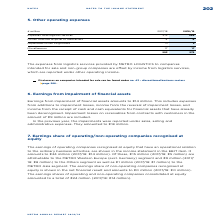According to Metro Ag's financial document, What is offset by income from logistics services? The expenses from logistics services provided by METRO LOGISTICS to companies intended for sale and non-group companies. The document states: "The expenses from logistics services provided by METRO LOGISTICS to companies intended for sale and non-group companies are offset by income from logi..." Also, Where is income from logistics services reported? reported under other operating income.. The document states: "which are reported under other operating income...." Also, What are the components under Other operating expenses in the table? The document contains multiple relevant values: Expenses from logistics services, Losses from the disposal of fixed assets, Impairment losses on goodwill, Miscellaneous. From the document: "Losses from the disposal of fixed assets 4 6 Miscellaneous 17 17 Impairment losses on goodwill 0 3 Expenses from logistics services 272 254..." Additionally, In which year was the amount of Losses from the disposal of fixed assets larger? Based on the financial document, the answer is 2018/2019. Also, can you calculate: What was the change in Losses from the disposal of fixed assets in 2018/2019 from 2017/2018? Based on the calculation: 6-4, the result is 2 (in millions). This is based on the information: "Losses from the disposal of fixed assets 4 6 Losses from the disposal of fixed assets 4 6..." The key data points involved are: 4, 6. Also, can you calculate: What was the percentage change in Losses from the disposal of fixed assets in 2018/2019 from 2017/2018? To answer this question, I need to perform calculations using the financial data. The calculation is: (6-4)/4, which equals 50 (percentage). This is based on the information: "Losses from the disposal of fixed assets 4 6 Losses from the disposal of fixed assets 4 6..." The key data points involved are: 4, 6. 